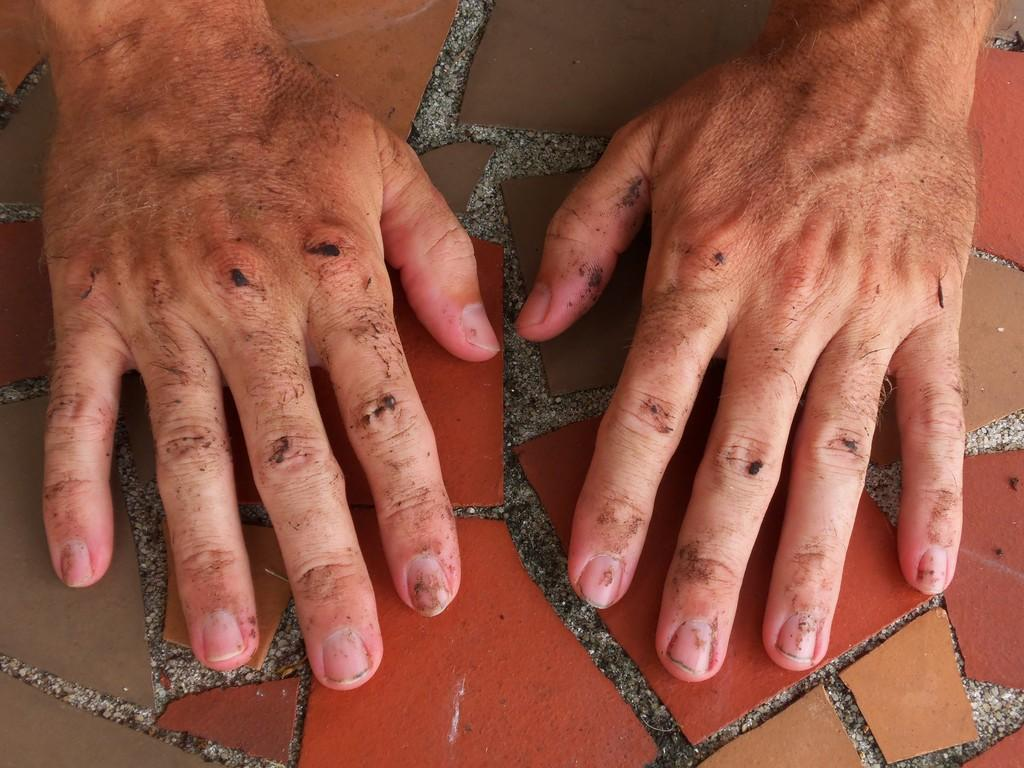What body part is visible in the image? There are hands of a man in the image. What is the position of the hands in the image? The hands are placed on the floor. What can be observed about the floor in the image? There are red and brown color tiles on the floor. How many cats can be seen playing with a bead in the wilderness in the image? There are no cats or beads present in the image, nor is there any wilderness depicted. 